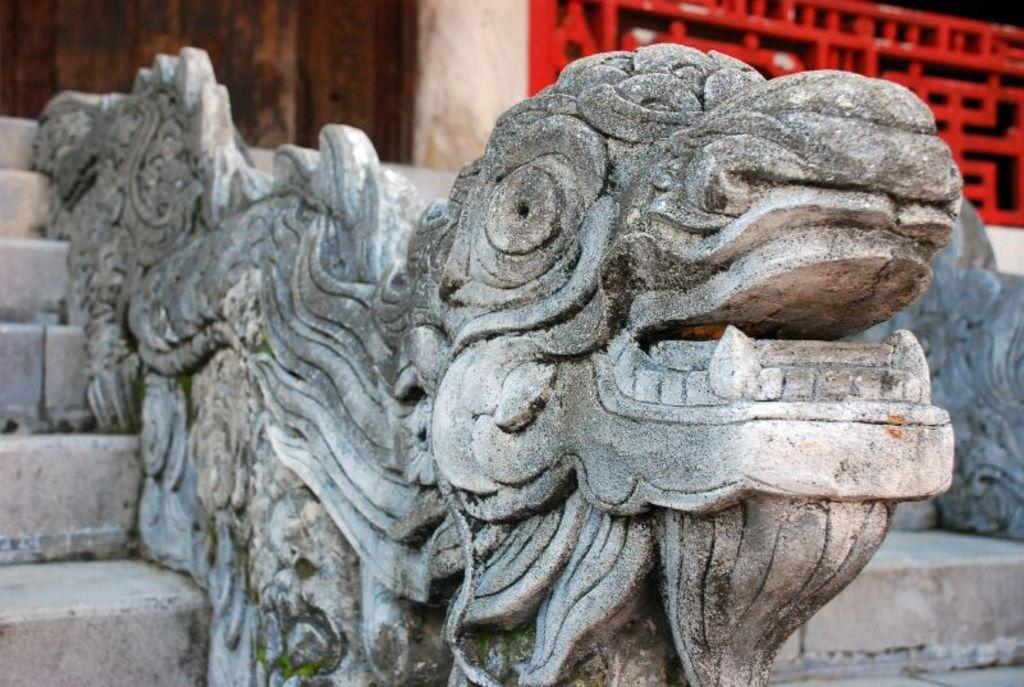What is the main subject in the image? There is a sculpture in the image. What architectural feature can be seen in the image? There are stairs in the image. What type of fencing is present in the image? There is red color fencing in the image. What is the background of the image? There is a wall in the image. What type of tail can be seen on the sculpture in the image? There is no tail present on the sculpture in the image. 